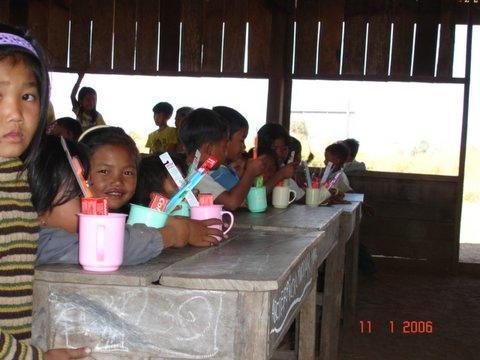How many people are visible?
Give a very brief answer. 4. 